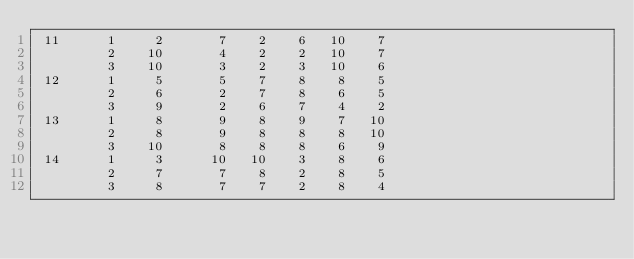Convert code to text. <code><loc_0><loc_0><loc_500><loc_500><_ObjectiveC_> 11      1     2       7    2    6   10    7
         2    10       4    2    2   10    7
         3    10       3    2    3   10    6
 12      1     5       5    7    8    8    5
         2     6       2    7    8    6    5
         3     9       2    6    7    4    2
 13      1     8       9    8    9    7   10
         2     8       9    8    8    8   10
         3    10       8    8    8    6    9
 14      1     3      10   10    3    8    6
         2     7       7    8    2    8    5
         3     8       7    7    2    8    4</code> 